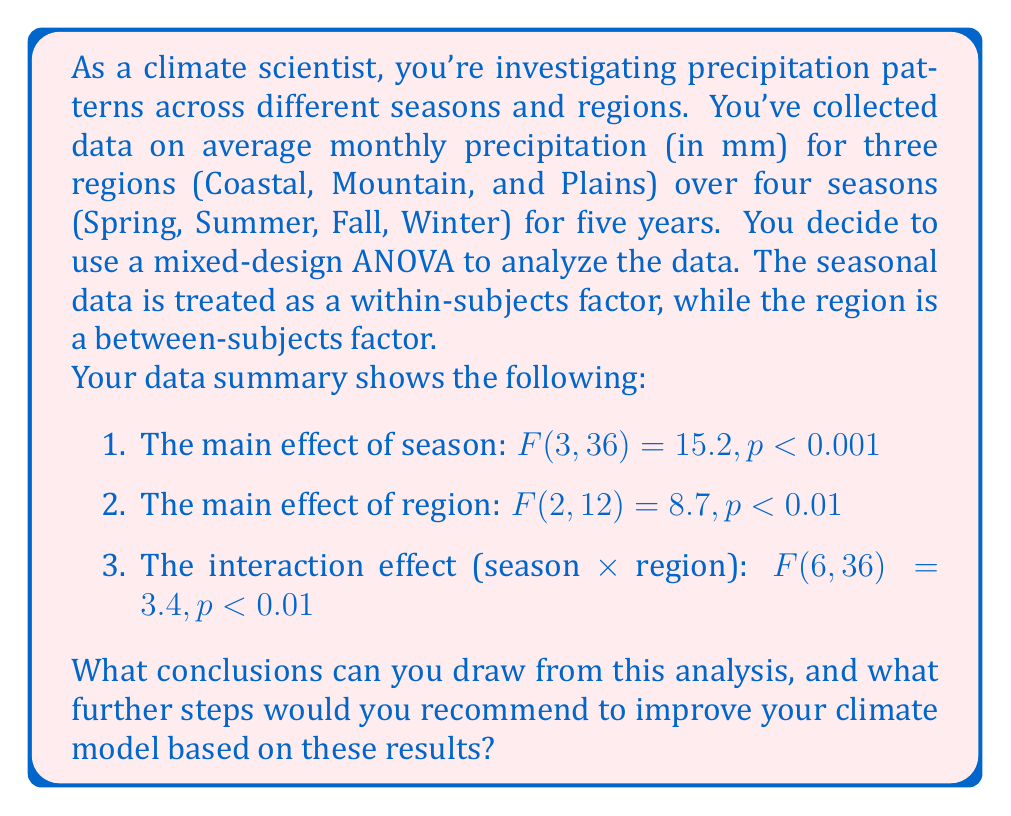Help me with this question. To interpret these results and draw conclusions, we need to understand each component of the mixed-design ANOVA:

1. Main effect of season: $F(3, 36) = 15.2, p < 0.001$
   This indicates a significant difference in precipitation across seasons, regardless of region. The very low p-value (p < 0.001) suggests strong evidence against the null hypothesis of no difference between seasons.

2. Main effect of region: $F(2, 12) = 8.7, p < 0.01$
   This shows a significant difference in precipitation across regions, regardless of season. The p-value (p < 0.01) indicates strong evidence against the null hypothesis of no difference between regions.

3. Interaction effect (season × region): $F(6, 36) = 3.4, p < 0.01$
   This significant interaction suggests that the effect of season on precipitation depends on the region, or vice versa. In other words, the seasonal patterns of precipitation differ across regions.

Conclusions:
a) Precipitation varies significantly across seasons, indicating strong seasonality in the climate system.
b) There are significant differences in precipitation between the Coastal, Mountain, and Plains regions.
c) The seasonal patterns of precipitation are not uniform across regions, suggesting complex interactions between local geography and large-scale climate patterns.

Recommended steps to improve the climate model:

1. Conduct post-hoc tests (e.g., Tukey's HSD) to determine which specific seasons and regions differ from each other.

2. Analyze the simple effects to understand how seasonal patterns differ in each region. This can be done by conducting separate one-way ANOVAs for each region.

3. Incorporate region-specific seasonal precipitation patterns into the climate model, rather than using a one-size-fits-all approach.

4. Investigate potential drivers of the observed differences, such as topography, distance from water bodies, or prevailing wind patterns.

5. Consider including additional variables that might explain the regional and seasonal variations, such as temperature, humidity, or atmospheric pressure.

6. Develop and test hypotheses about the physical mechanisms behind the observed interactions between season and region.

7. Use the findings to refine spatial and temporal resolutions in the climate model, focusing on areas and time periods with the most significant variations.

8. Validate the improved model using cross-validation techniques or by testing it on independent datasets from similar climatic regions.
Answer: The analysis reveals significant main effects of both season and region on precipitation, as well as a significant interaction between the two factors. This indicates that precipitation patterns vary across seasons and regions, and that the seasonal patterns differ between regions. To improve the climate model, it is recommended to conduct post-hoc tests, analyze simple effects, incorporate region-specific seasonal patterns, investigate drivers of observed differences, include additional relevant variables, develop hypotheses about underlying mechanisms, refine model resolutions, and validate the improved model. 